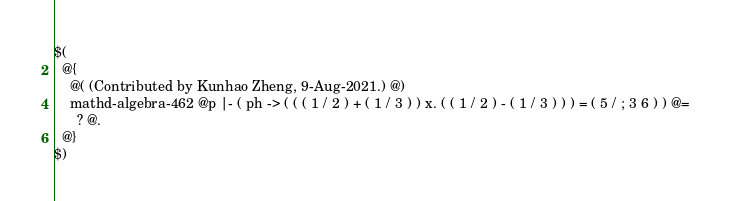Convert code to text. <code><loc_0><loc_0><loc_500><loc_500><_ObjectiveC_>$(
  @{
    @( (Contributed by Kunhao Zheng, 9-Aug-2021.) @)
    mathd-algebra-462 @p |- ( ph -> ( ( ( 1 / 2 ) + ( 1 / 3 ) ) x. ( ( 1 / 2 ) - ( 1 / 3 ) ) ) = ( 5 / ; 3 6 ) ) @=
      ? @.
  @}
$)
</code> 